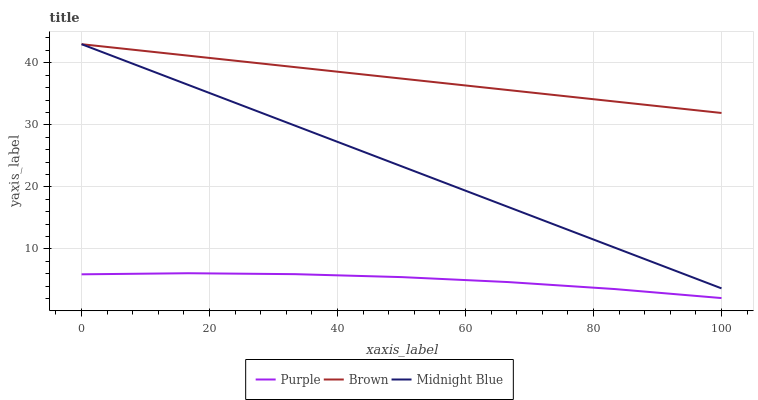Does Purple have the minimum area under the curve?
Answer yes or no. Yes. Does Brown have the maximum area under the curve?
Answer yes or no. Yes. Does Midnight Blue have the minimum area under the curve?
Answer yes or no. No. Does Midnight Blue have the maximum area under the curve?
Answer yes or no. No. Is Midnight Blue the smoothest?
Answer yes or no. Yes. Is Purple the roughest?
Answer yes or no. Yes. Is Brown the smoothest?
Answer yes or no. No. Is Brown the roughest?
Answer yes or no. No. Does Purple have the lowest value?
Answer yes or no. Yes. Does Midnight Blue have the lowest value?
Answer yes or no. No. Does Midnight Blue have the highest value?
Answer yes or no. Yes. Is Purple less than Brown?
Answer yes or no. Yes. Is Midnight Blue greater than Purple?
Answer yes or no. Yes. Does Brown intersect Midnight Blue?
Answer yes or no. Yes. Is Brown less than Midnight Blue?
Answer yes or no. No. Is Brown greater than Midnight Blue?
Answer yes or no. No. Does Purple intersect Brown?
Answer yes or no. No. 